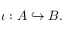Convert formula to latex. <formula><loc_0><loc_0><loc_500><loc_500>\iota \colon A \hookrightarrow B .</formula> 